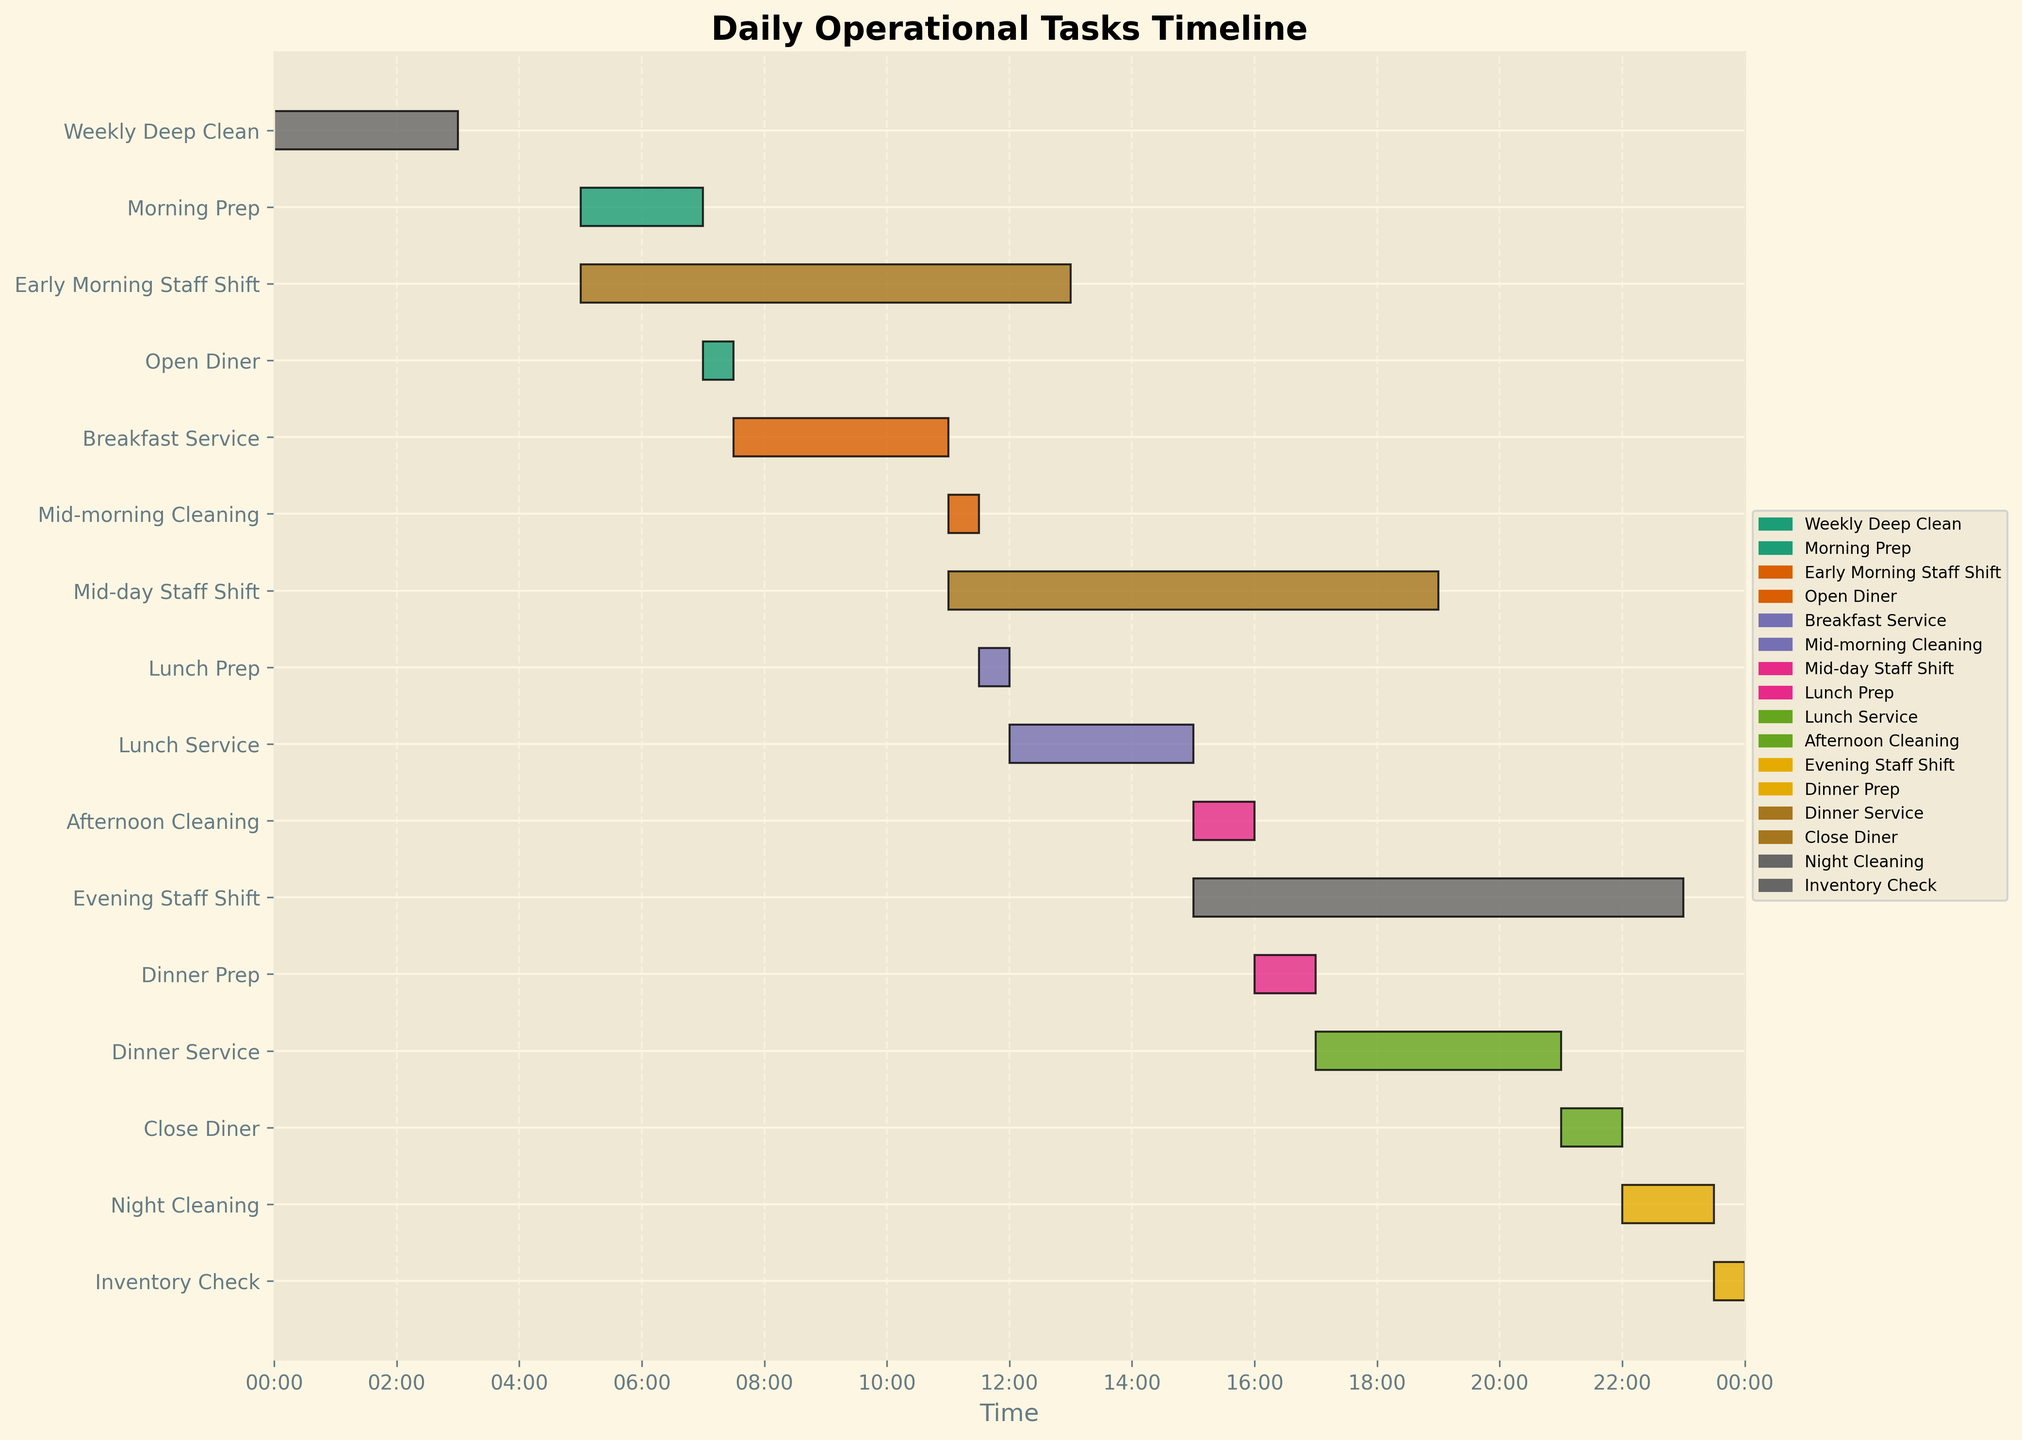What's the title of the Gantt Chart? The title is usually displayed at the top of the chart. In this case, it is "Daily Operational Tasks Timeline" because that's provided in the title argument of plt.title().
Answer: Daily Operational Tasks Timeline What time does the Breakfast Service end? By tracing the "Breakfast Service" bar on the Gantt Chart, we can see it starts at 07:30 and ends at 11:00.
Answer: 11:00 During which hours does the Early Morning Staff Shift operate? Look for the "Early Morning Staff Shift" task bar. It starts at 05:00 and ends at 13:00.
Answer: 05:00 to 13:00 Which task has the shortest duration? Compare the length of all task bars. According to the task list, "Open Diner" (07:00 to 07:30) is the shortest task, lasting only 30 minutes.
Answer: Open Diner What tasks are scheduled after Dinner Service? Observe the timeline after the "Dinner Service" bar ends at 21:00. The tasks include "Close Diner" (21:00 to 22:00), "Night Cleaning" (22:00 to 23:30), and "Inventory Check" (23:30 to 00:00).
Answer: Close Diner, Night Cleaning, Inventory Check How long breaks happen between tasks? To answer: calculate the gaps between task bars. For example, there's a 30-minute break between "Late-night Cleaning" (23:30) and "Weekly Deep Clean" (00:00).
Answer: Varies Do any tasks overlap with staff shifts? Examine the alignment of task bars with staff shift bars. For instance, the "Lunch Service" (12:00 to 15:00) overlaps with both "Early Morning Staff Shift" and "Mid-day Staff Shift."
Answer: Yes Which tasks cover the opening and closing of the diner? Based on the labels, "Open Diner" (07:00 to 07:30) and "Close Diner" (21:00 to 22:00) are responsible for opening and closing the diner respectively.
Answer: Open Diner, Close Diner What's the longest continuous period of tasks with no breaks? Look for contiguous, back-to-back tasks without gaps. The period from 12:00 "Lunch Service" to 16:00 "Afternoon Cleaning" covers several hours continuously.
Answer: 12:00 to 16:00 What time does the Weekly Deep Clean start, and how long does it last? "Weekly Deep Clean" starts at 00:00 and ends at 03:00. This gives it a duration of 3 hours.
Answer: Starts at 00:00, lasts 3 hours 